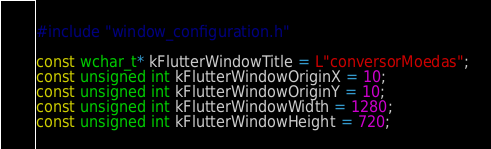<code> <loc_0><loc_0><loc_500><loc_500><_C++_>#include "window_configuration.h"

const wchar_t* kFlutterWindowTitle = L"conversorMoedas";
const unsigned int kFlutterWindowOriginX = 10;
const unsigned int kFlutterWindowOriginY = 10;
const unsigned int kFlutterWindowWidth = 1280;
const unsigned int kFlutterWindowHeight = 720;
</code> 